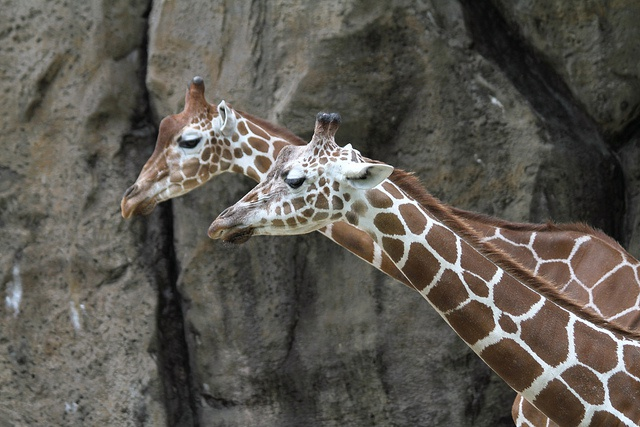Describe the objects in this image and their specific colors. I can see giraffe in gray, lightgray, maroon, and darkgray tones and giraffe in gray, darkgray, and maroon tones in this image. 